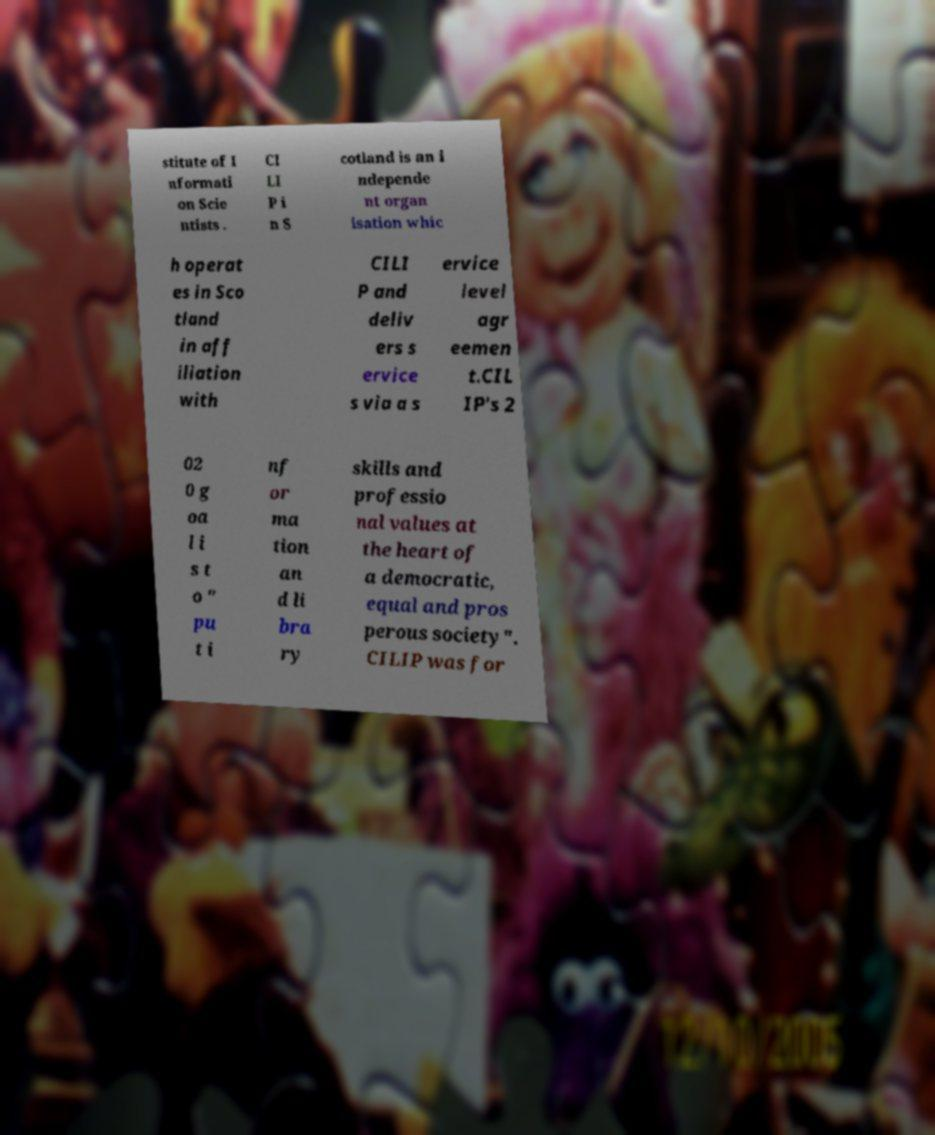For documentation purposes, I need the text within this image transcribed. Could you provide that? stitute of I nformati on Scie ntists . CI LI P i n S cotland is an i ndepende nt organ isation whic h operat es in Sco tland in aff iliation with CILI P and deliv ers s ervice s via a s ervice level agr eemen t.CIL IP's 2 02 0 g oa l i s t o " pu t i nf or ma tion an d li bra ry skills and professio nal values at the heart of a democratic, equal and pros perous society". CILIP was for 